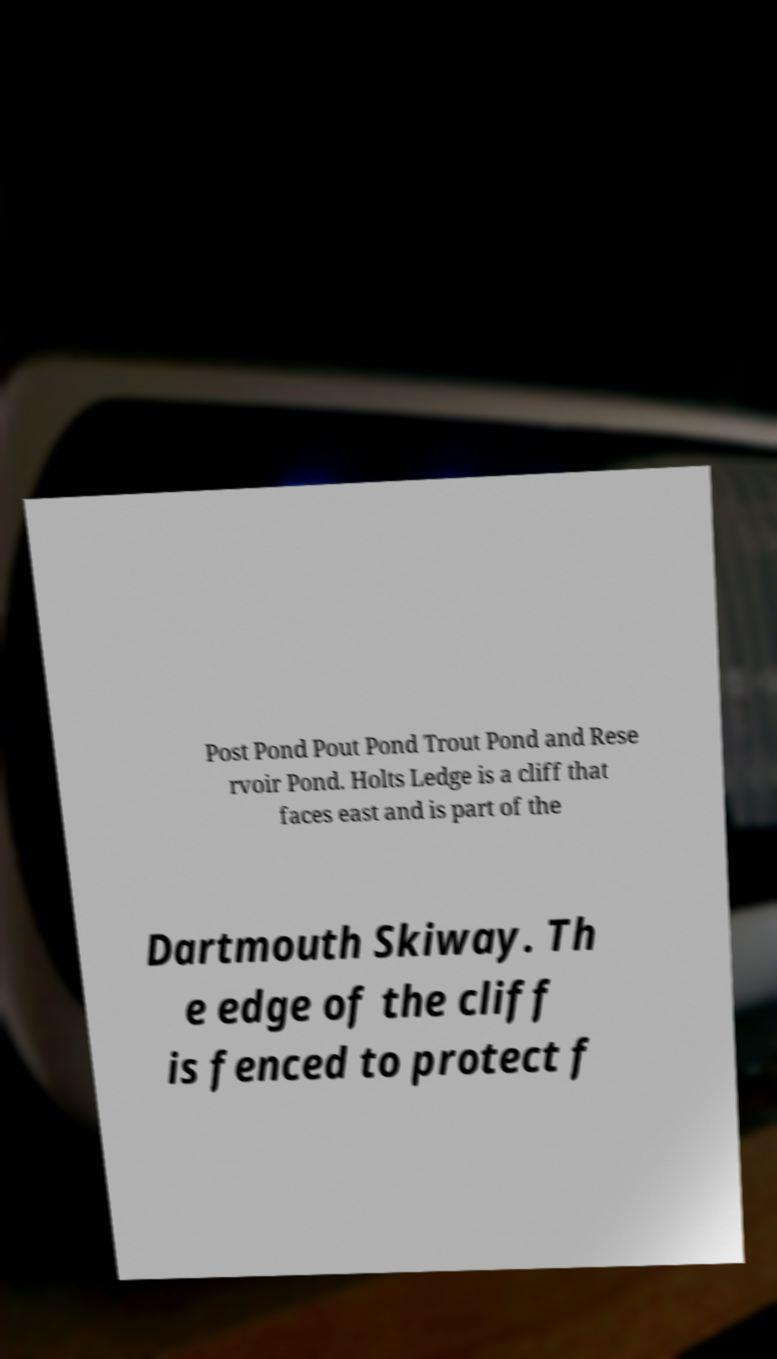Please identify and transcribe the text found in this image. Post Pond Pout Pond Trout Pond and Rese rvoir Pond. Holts Ledge is a cliff that faces east and is part of the Dartmouth Skiway. Th e edge of the cliff is fenced to protect f 